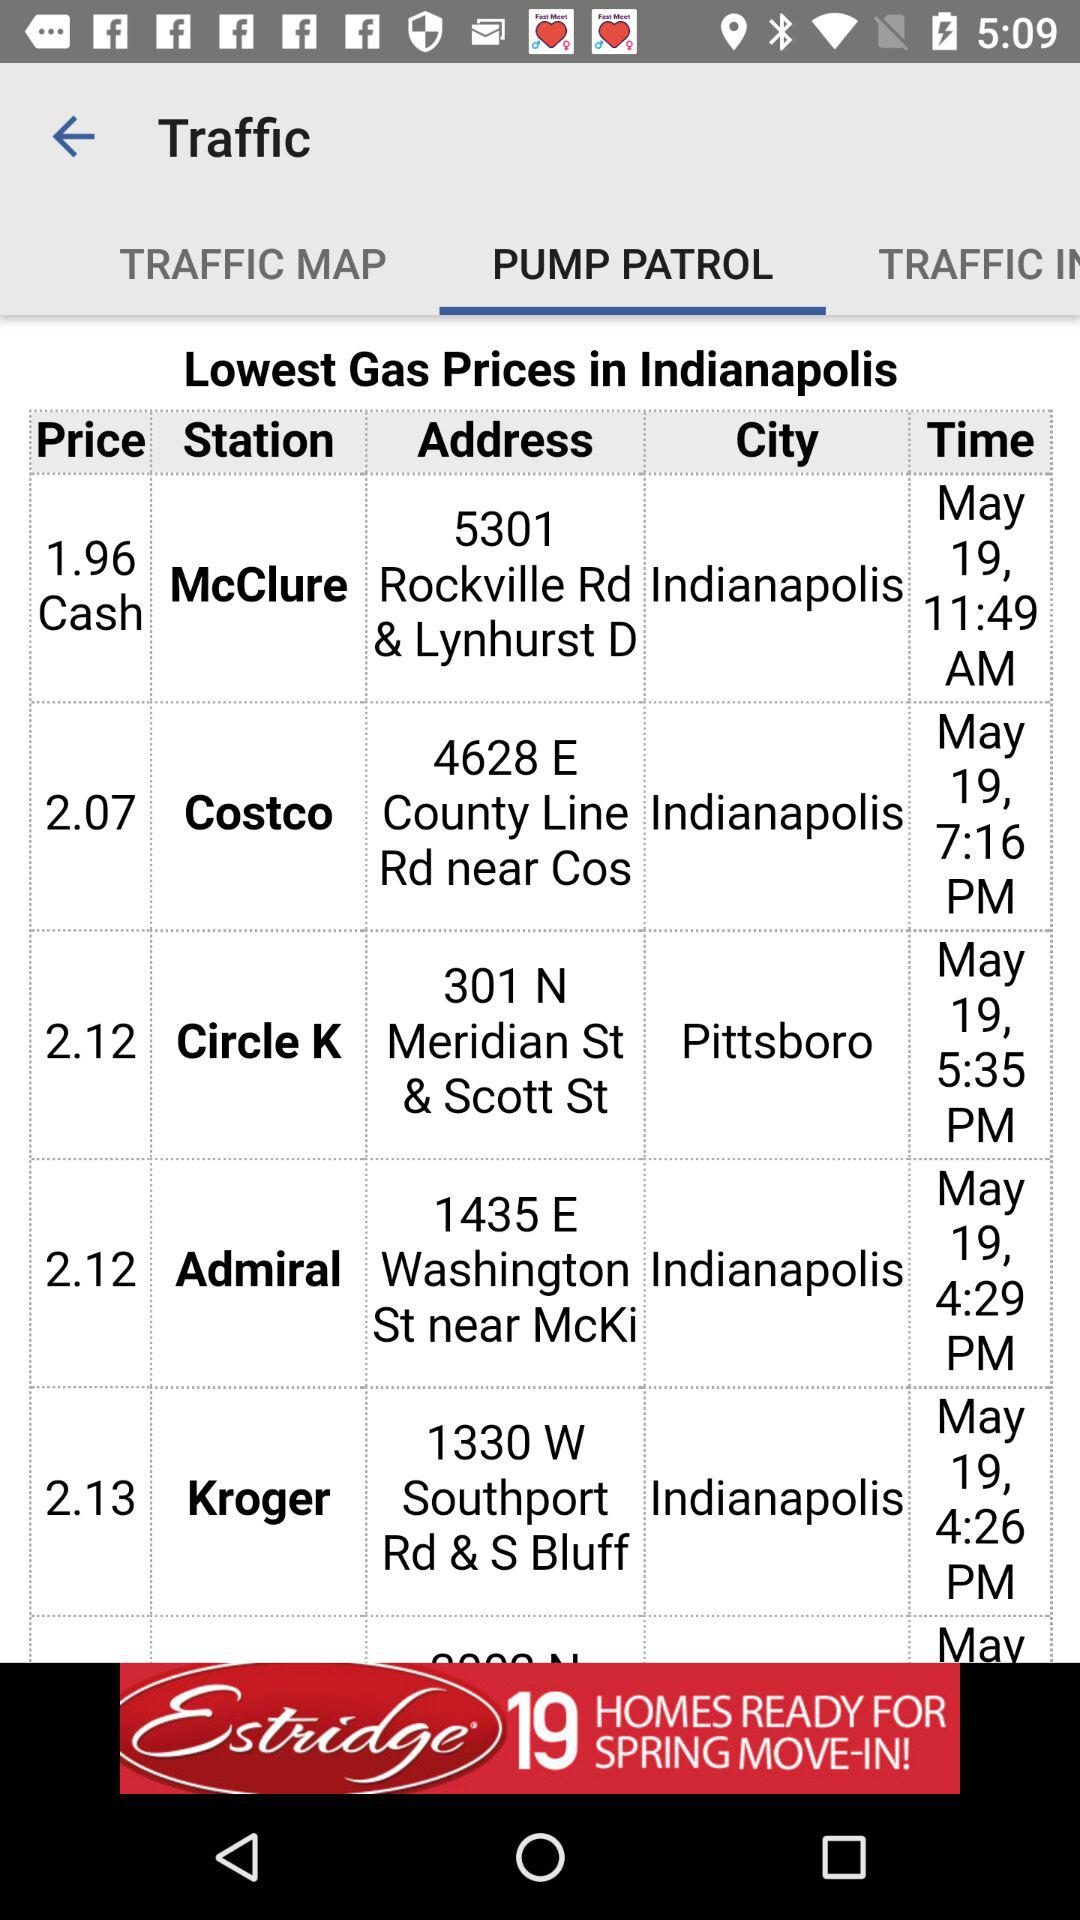Which tab is selected? The selected tab is Pump Patrol. 